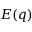Convert formula to latex. <formula><loc_0><loc_0><loc_500><loc_500>E ( q )</formula> 